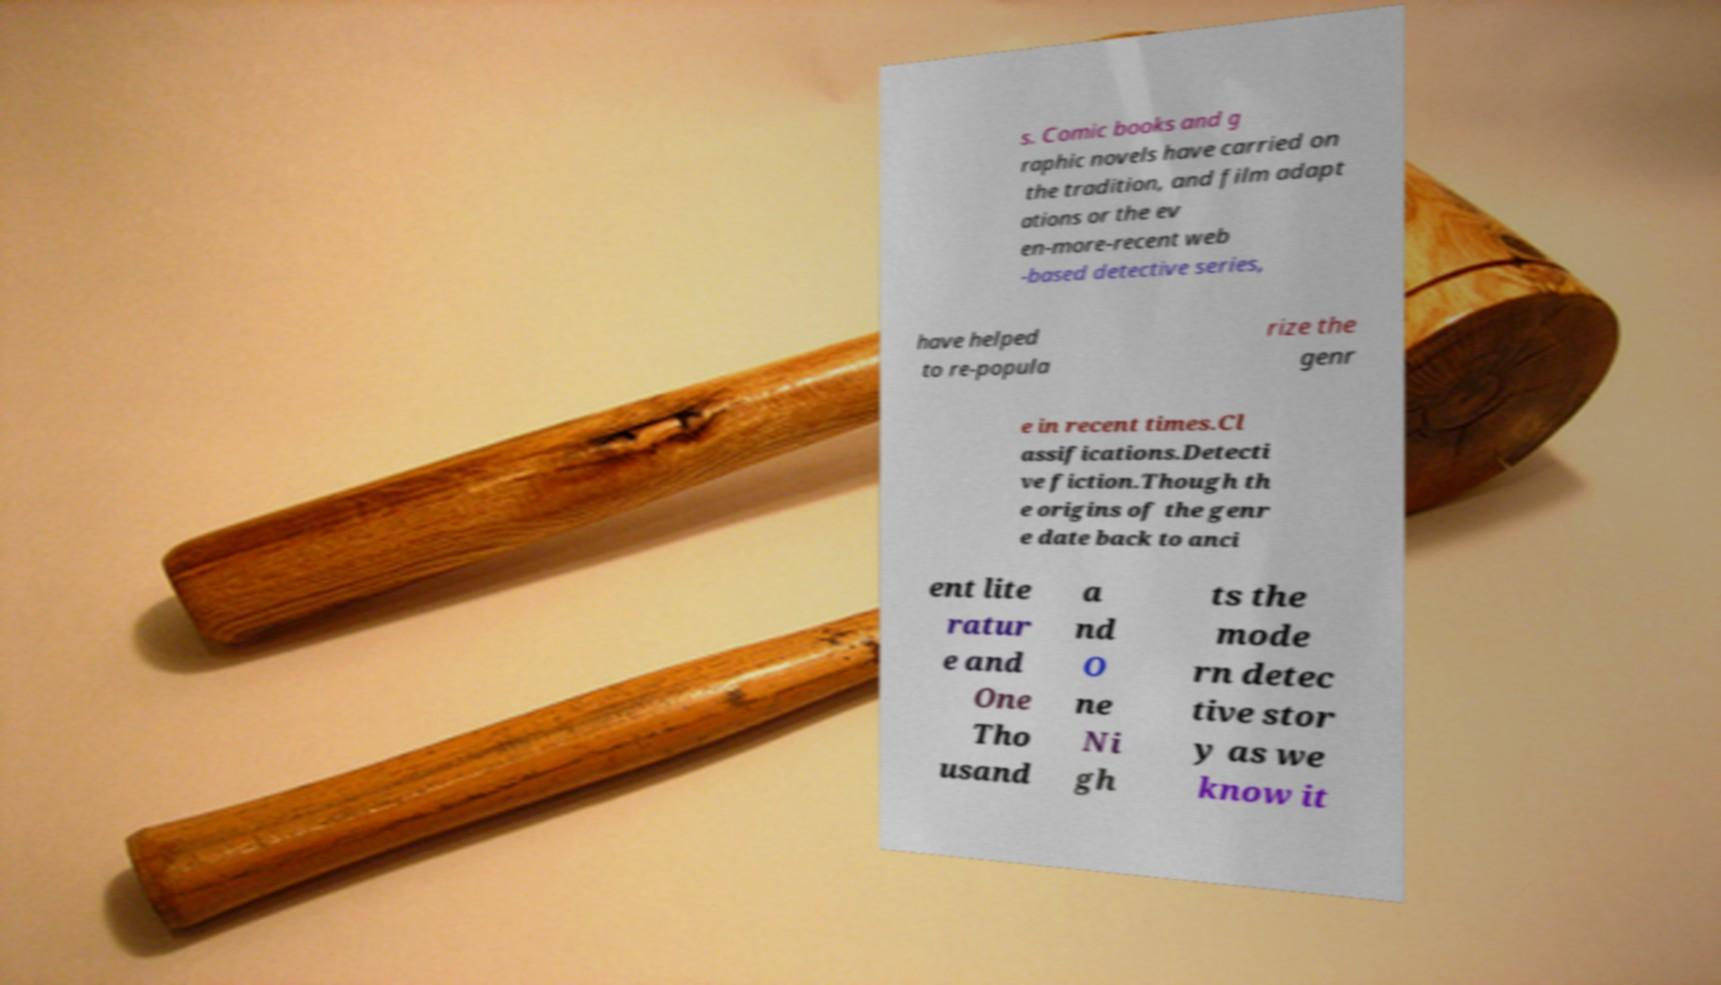Please read and relay the text visible in this image. What does it say? s. Comic books and g raphic novels have carried on the tradition, and film adapt ations or the ev en-more-recent web -based detective series, have helped to re-popula rize the genr e in recent times.Cl assifications.Detecti ve fiction.Though th e origins of the genr e date back to anci ent lite ratur e and One Tho usand a nd O ne Ni gh ts the mode rn detec tive stor y as we know it 